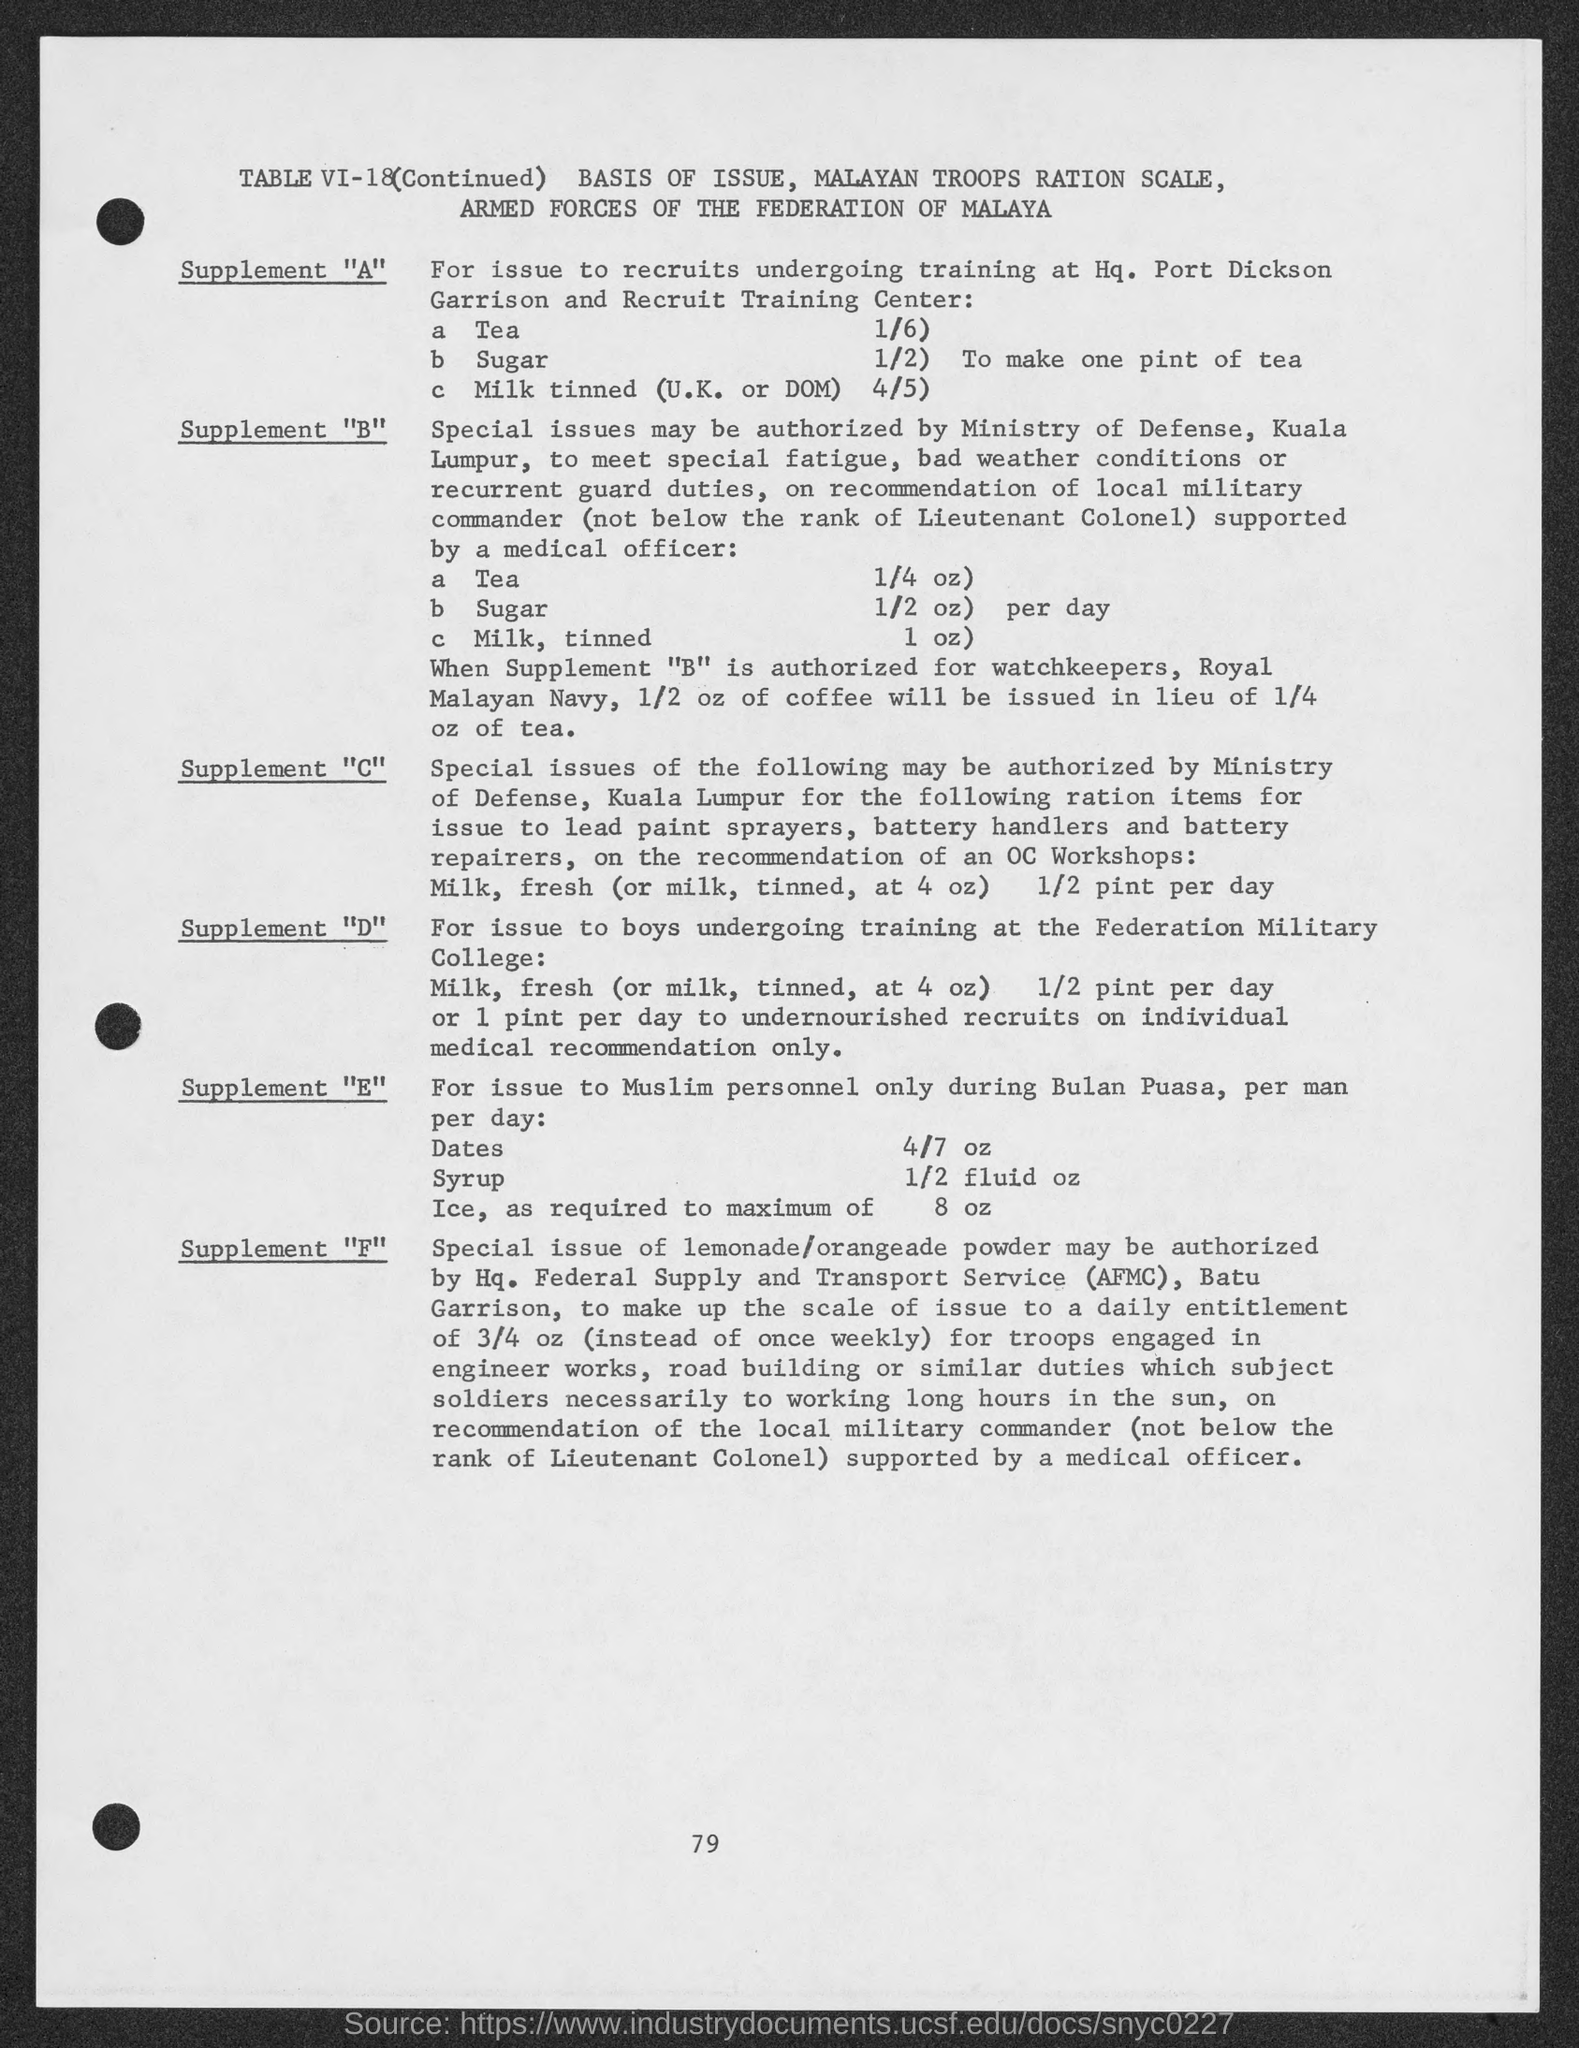Draw attention to some important aspects in this diagram. The table number is VI-18. 